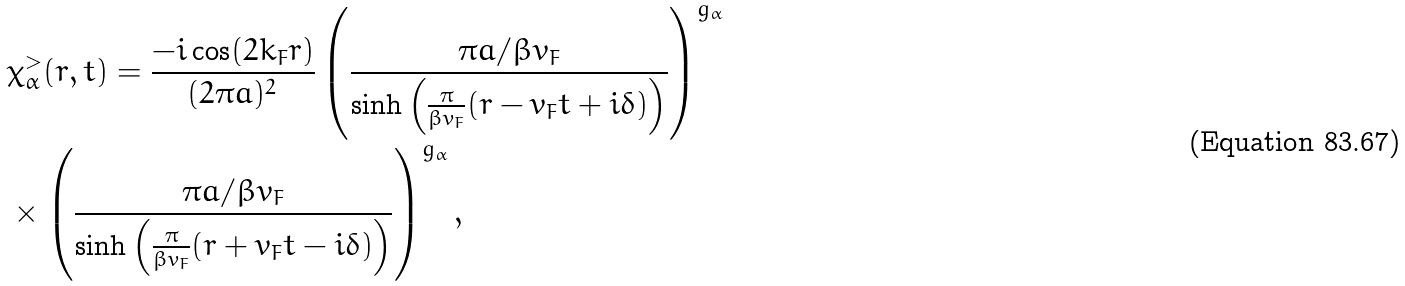<formula> <loc_0><loc_0><loc_500><loc_500>& \chi ^ { > } _ { \alpha } ( r , t ) = \frac { - i \cos ( 2 k _ { F } r ) } { ( 2 \pi a ) ^ { 2 } } \left ( \frac { \pi a / \beta v _ { F } } { \sinh \left ( \frac { \pi } { \beta v _ { F } } ( r - v _ { F } t + i \delta ) \right ) } \right ) ^ { g _ { \alpha } } \\ & \times \left ( \frac { \pi a / \beta v _ { F } } { \sinh \left ( \frac { \pi } { \beta v _ { F } } ( r + v _ { F } t - i \delta ) \right ) } \right ) ^ { g _ { \alpha } } ,</formula> 